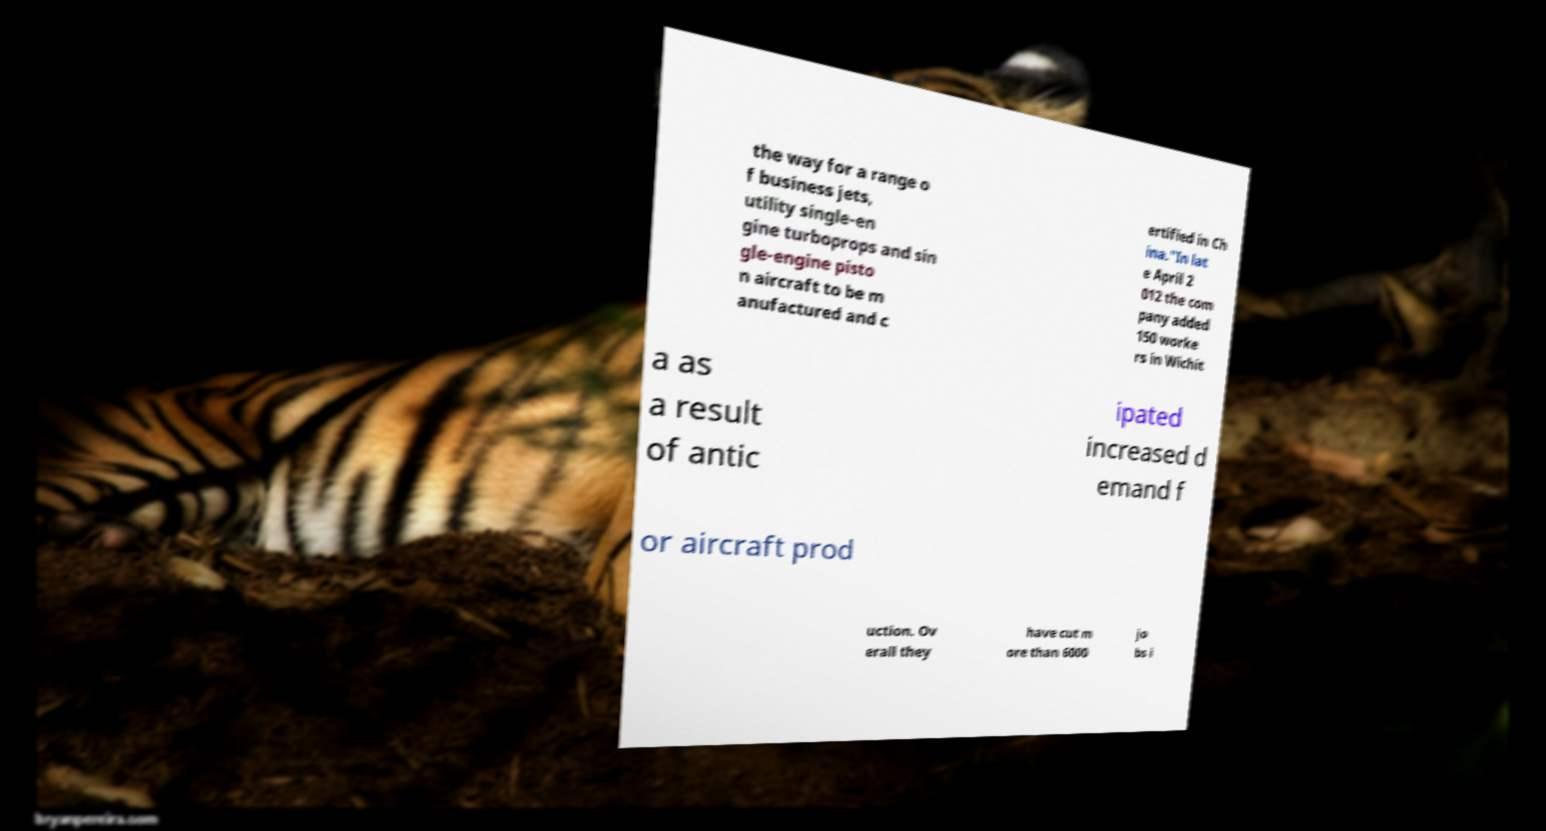There's text embedded in this image that I need extracted. Can you transcribe it verbatim? the way for a range o f business jets, utility single-en gine turboprops and sin gle-engine pisto n aircraft to be m anufactured and c ertified in Ch ina."In lat e April 2 012 the com pany added 150 worke rs in Wichit a as a result of antic ipated increased d emand f or aircraft prod uction. Ov erall they have cut m ore than 6000 jo bs i 